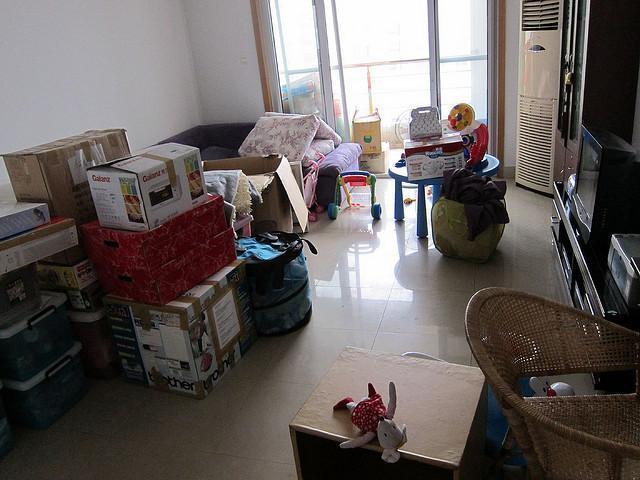How many teddy bears can you see?
Give a very brief answer. 1. How many couches are visible?
Give a very brief answer. 1. 